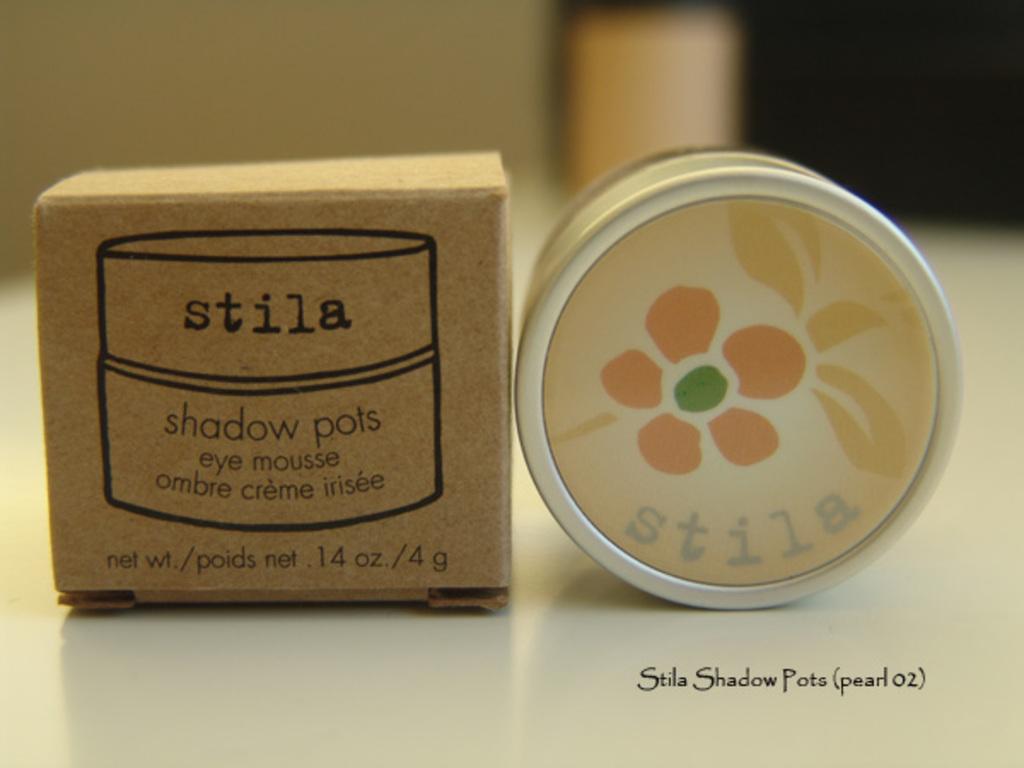What is the product?
Provide a succinct answer. Eye mousse. What is the use of this product?
Give a very brief answer. Eye mousse. 